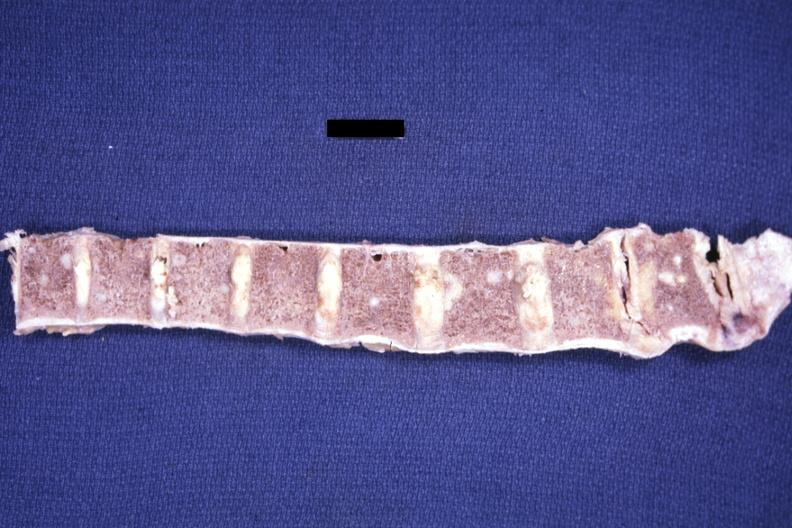what does this image show?
Answer the question using a single word or phrase. Fixed tissue easily seen metastases not the best photo technic adenoca from lung 